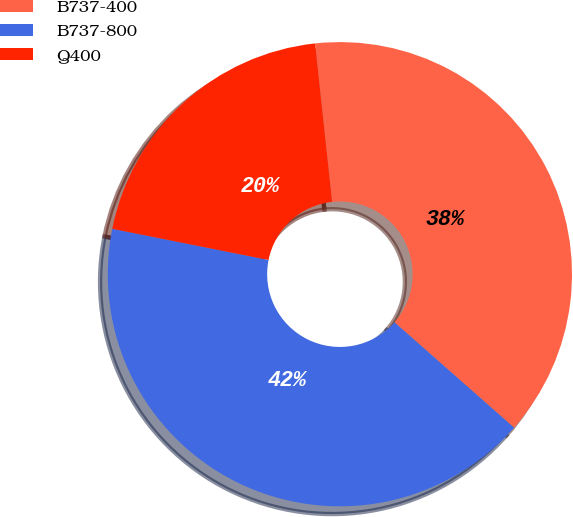Convert chart to OTSL. <chart><loc_0><loc_0><loc_500><loc_500><pie_chart><fcel>B737-400<fcel>B737-800<fcel>Q400<nl><fcel>38.2%<fcel>41.64%<fcel>20.16%<nl></chart> 